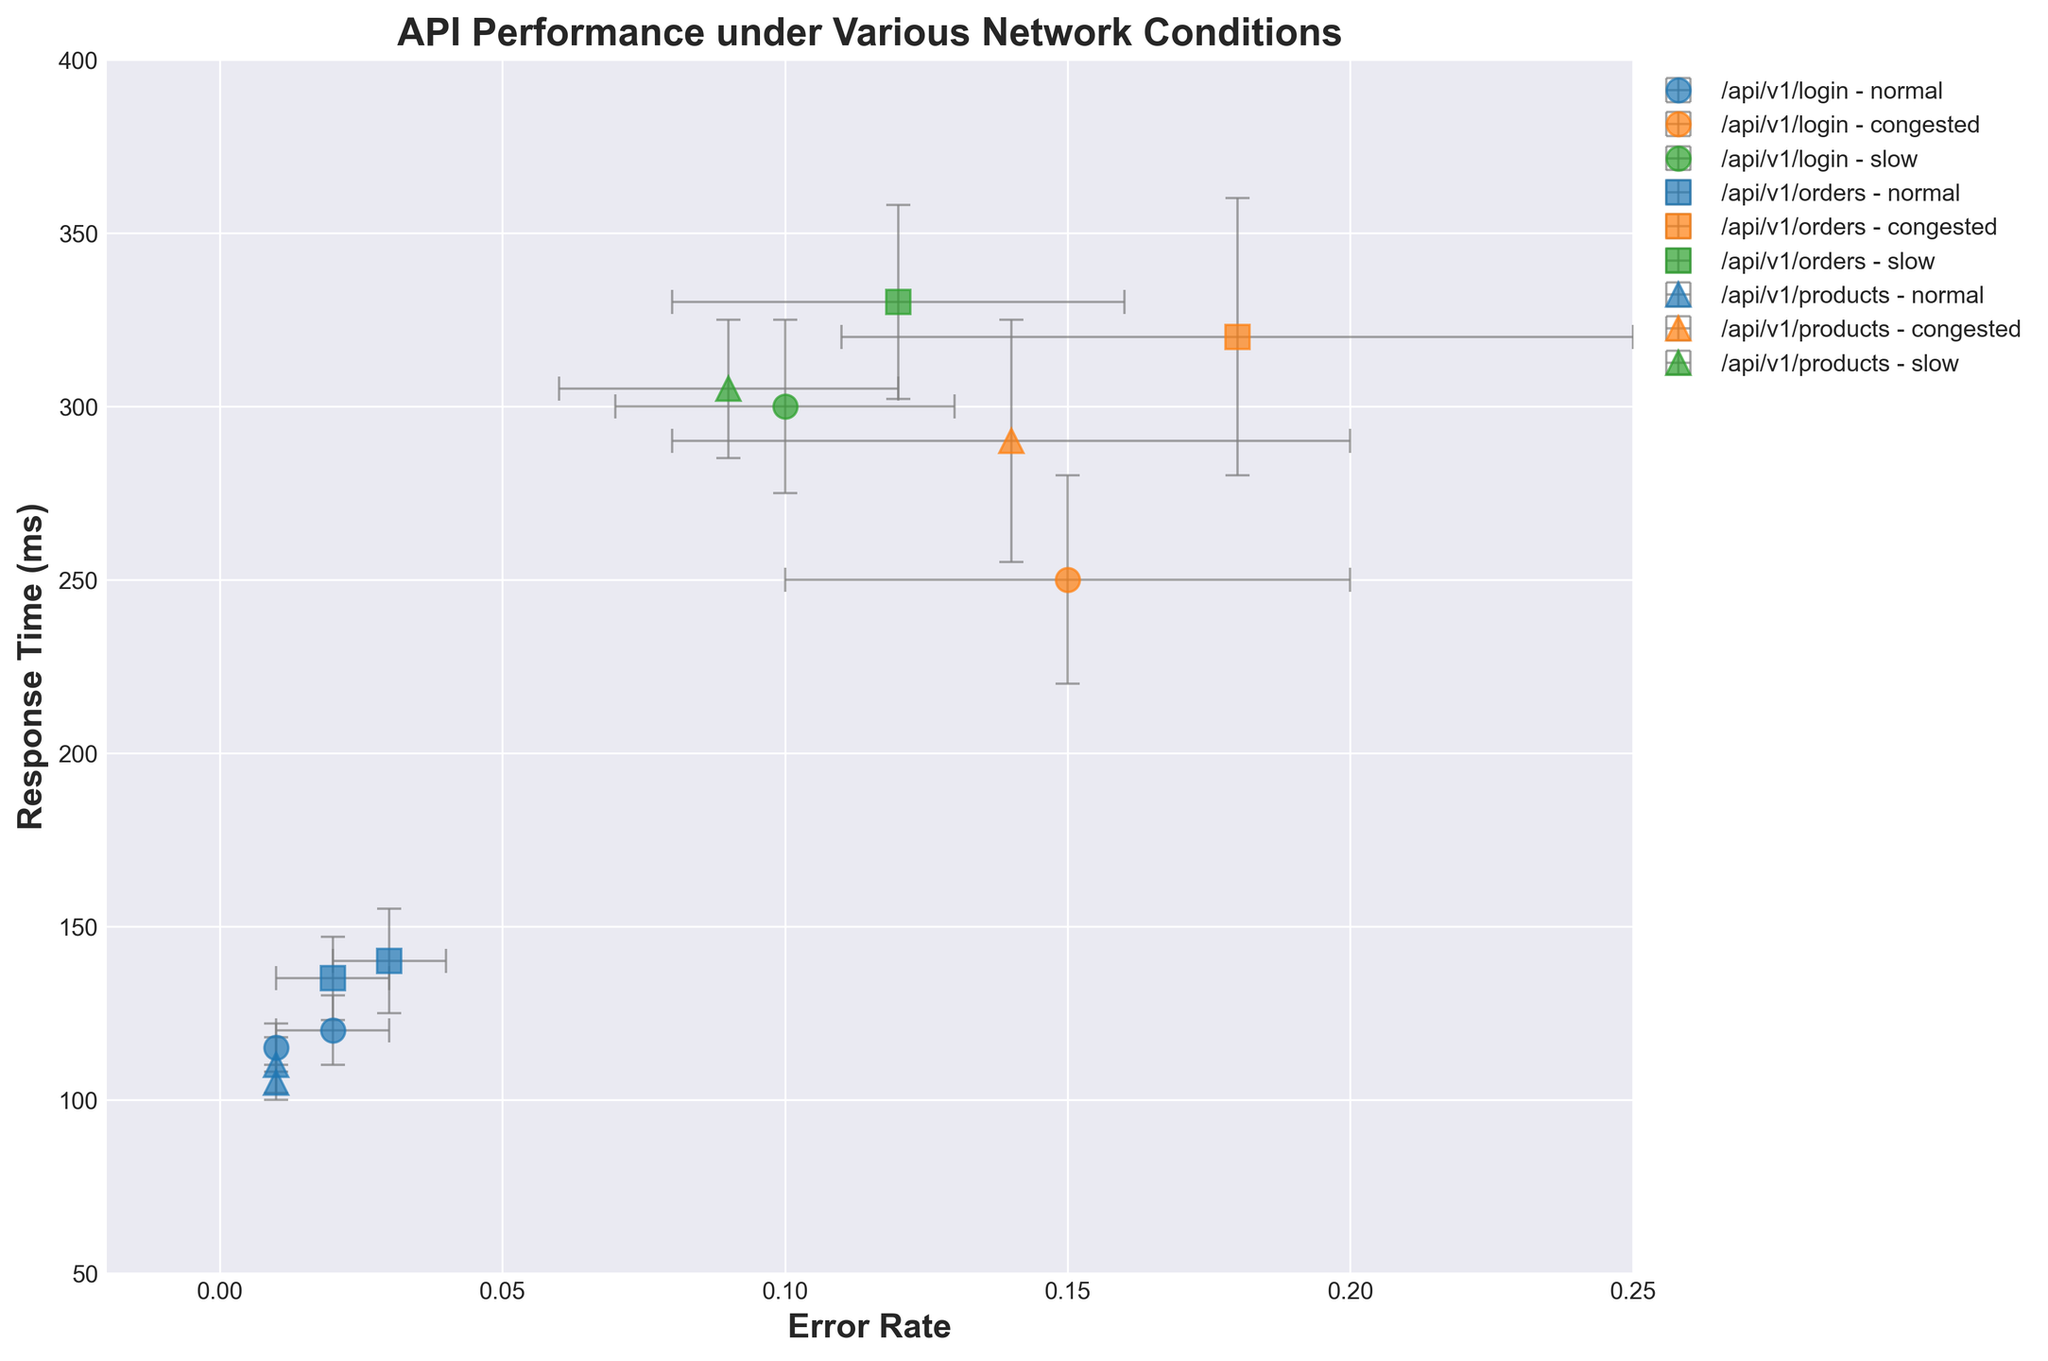What is the title of the plot? The title is displayed prominently at the top of the plot, indicating what the figure is about. The title reads "API Performance under Various Network Conditions", summarizing the context and the focus of the visualization.
Answer: API Performance under Various Network Conditions How many different API endpoints are compared in the figure? By analyzing different markers in the plot, there are three distinct API endpoints being compared: `/api/v1/login`, `/api/v1/orders`, and `/api/v1/products`. These are represented by circles, squares, and triangles respectively.
Answer: 3 What is the relationship between the error rate and response time for the `/api/v1/login` endpoint under congested network conditions? For the `/api/v1/login` with congested conditions, the error rate is high around 0.15 with a response time of approximately 250 ms. This implies that as the network gets congested, both error rate and response times increase significantly.
Answer: Both high Which network condition shows the highest response times for any API endpoint? Examining different markers and colors, the slow network condition (green color) shows the highest response times for each API endpoint. Specifically, it reaches around 330 ms for `/api/v1/orders` and 305 ms for `/api/v1/products`.
Answer: Slow network condition Which API endpoint has the lowest error rate under normal network conditions? Under the normal network condition (blue color), the `/api/v1/products` endpoint displays the lowest error rate, at approximately 0.01.
Answer: /api/v1/products By how much does the response time change for the `/api/v1/orders` endpoint from normal to congested network conditions? The response time for `/api/v1/orders` under normal conditions is around 140 ms, while under congested conditions it rises to about 320 ms. The difference is computed as 320 - 140 = 180 ms.
Answer: 180 ms What is the approximate range of error rates observed under slow network conditions? Observing the green markers, error rates under slow conditions vary from approximately 0.09 to 0.12. For all API endpoints, these values provide insights into the boundaries of error rates under this network state.
Answer: 0.09 to 0.12 Is there any endpoint that exhibits a lower error rate under congested conditions compared to normal conditions? By comparing the error rates for all endpoints, none of the API endpoints show a lower error rate under congested conditions relative to normal conditions. The error rates are consistently higher when the network is congested.
Answer: No How does the standard deviation of response times for `/api/v1/products` compare between normal and congested conditions? For `/api/v1/products`, the stddev for response times under normal conditions is about 8 ms, while under congested conditions it is around 35 ms. We can see that the variation is significantly higher under congestion by a difference of 35 - 8 = 27 ms.
Answer: 27 ms higher 